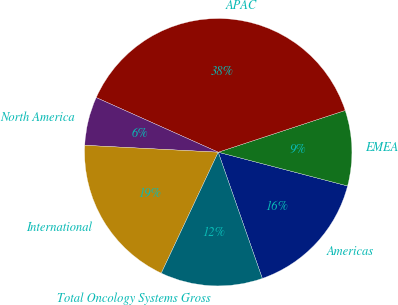Convert chart. <chart><loc_0><loc_0><loc_500><loc_500><pie_chart><fcel>Americas<fcel>EMEA<fcel>APAC<fcel>North America<fcel>International<fcel>Total Oncology Systems Gross<nl><fcel>15.59%<fcel>9.12%<fcel>38.24%<fcel>5.88%<fcel>18.82%<fcel>12.35%<nl></chart> 